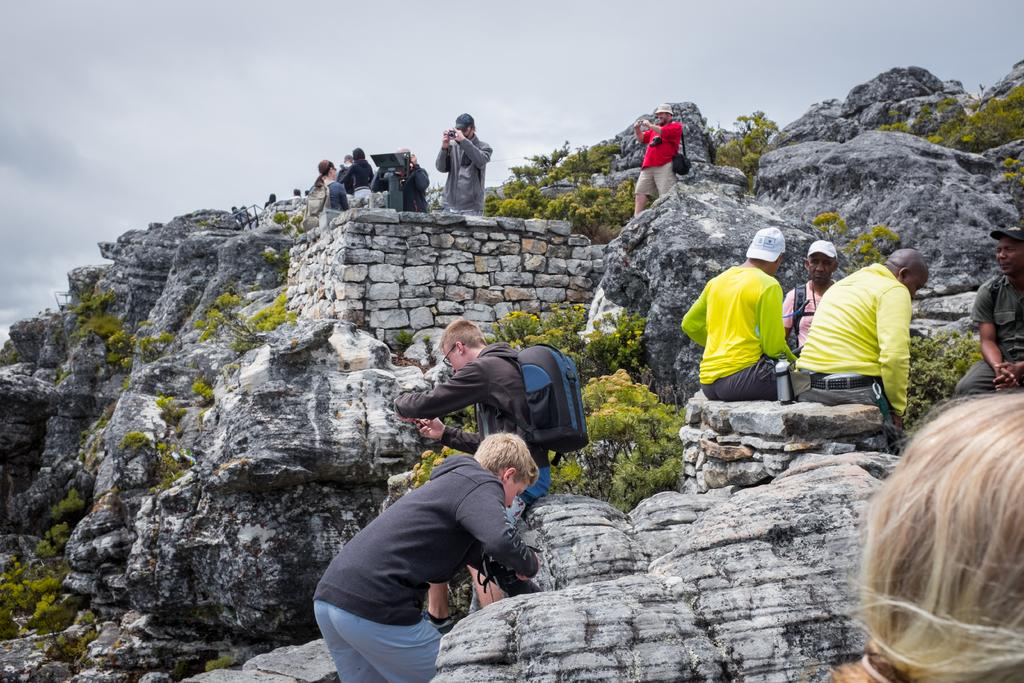Who or what can be seen in the image? There are people in the image. What natural elements are present in the image? There are rocks, trees, and the sky visible in the image. What objects can be seen in the image? There are bags, a bottle, and cameras in the image. What is visible in the background of the image? The sky is visible in the background of the image, with clouds present. What type of volleyball apparatus is being used in the image? There is no volleyball apparatus present in the image. What punishment is being administered to the people in the image? There is no punishment being administered to the people in the image; they are simply present in the scene. 